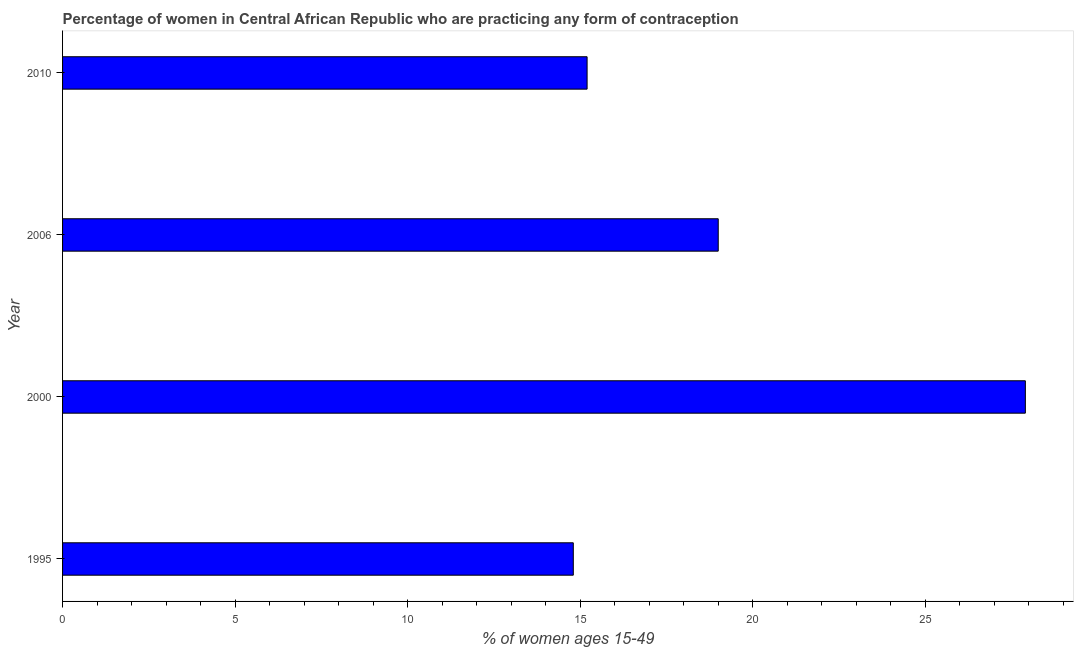Does the graph contain any zero values?
Give a very brief answer. No. Does the graph contain grids?
Provide a succinct answer. No. What is the title of the graph?
Provide a short and direct response. Percentage of women in Central African Republic who are practicing any form of contraception. What is the label or title of the X-axis?
Provide a short and direct response. % of women ages 15-49. What is the label or title of the Y-axis?
Your answer should be compact. Year. What is the contraceptive prevalence in 2006?
Give a very brief answer. 19. Across all years, what is the maximum contraceptive prevalence?
Your response must be concise. 27.9. What is the sum of the contraceptive prevalence?
Give a very brief answer. 76.9. What is the average contraceptive prevalence per year?
Your answer should be compact. 19.23. What is the ratio of the contraceptive prevalence in 1995 to that in 2006?
Offer a very short reply. 0.78. Is the contraceptive prevalence in 1995 less than that in 2010?
Ensure brevity in your answer.  Yes. Is the difference between the contraceptive prevalence in 1995 and 2000 greater than the difference between any two years?
Your answer should be compact. Yes. What is the difference between the highest and the second highest contraceptive prevalence?
Offer a terse response. 8.9. In how many years, is the contraceptive prevalence greater than the average contraceptive prevalence taken over all years?
Offer a very short reply. 1. How many bars are there?
Give a very brief answer. 4. How many years are there in the graph?
Keep it short and to the point. 4. What is the difference between two consecutive major ticks on the X-axis?
Your answer should be compact. 5. What is the % of women ages 15-49 of 2000?
Give a very brief answer. 27.9. What is the % of women ages 15-49 of 2006?
Provide a short and direct response. 19. What is the difference between the % of women ages 15-49 in 1995 and 2000?
Ensure brevity in your answer.  -13.1. What is the difference between the % of women ages 15-49 in 1995 and 2006?
Keep it short and to the point. -4.2. What is the difference between the % of women ages 15-49 in 1995 and 2010?
Make the answer very short. -0.4. What is the difference between the % of women ages 15-49 in 2000 and 2006?
Your answer should be compact. 8.9. What is the ratio of the % of women ages 15-49 in 1995 to that in 2000?
Your answer should be compact. 0.53. What is the ratio of the % of women ages 15-49 in 1995 to that in 2006?
Keep it short and to the point. 0.78. What is the ratio of the % of women ages 15-49 in 1995 to that in 2010?
Give a very brief answer. 0.97. What is the ratio of the % of women ages 15-49 in 2000 to that in 2006?
Ensure brevity in your answer.  1.47. What is the ratio of the % of women ages 15-49 in 2000 to that in 2010?
Make the answer very short. 1.84. What is the ratio of the % of women ages 15-49 in 2006 to that in 2010?
Offer a very short reply. 1.25. 